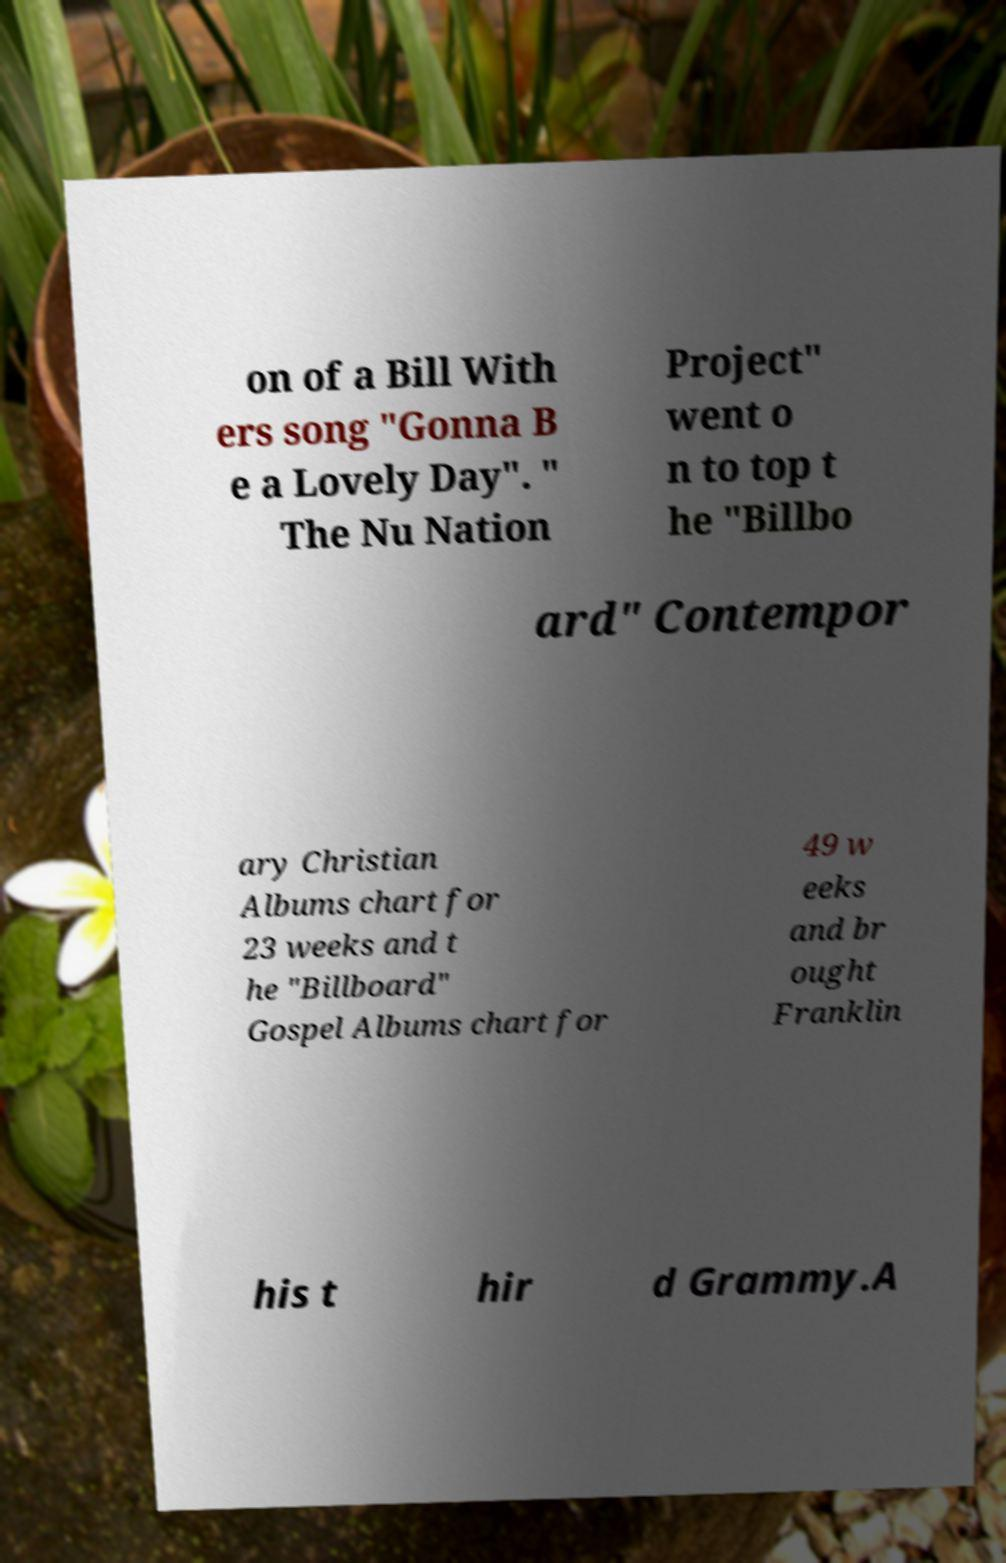Can you accurately transcribe the text from the provided image for me? on of a Bill With ers song "Gonna B e a Lovely Day". " The Nu Nation Project" went o n to top t he "Billbo ard" Contempor ary Christian Albums chart for 23 weeks and t he "Billboard" Gospel Albums chart for 49 w eeks and br ought Franklin his t hir d Grammy.A 